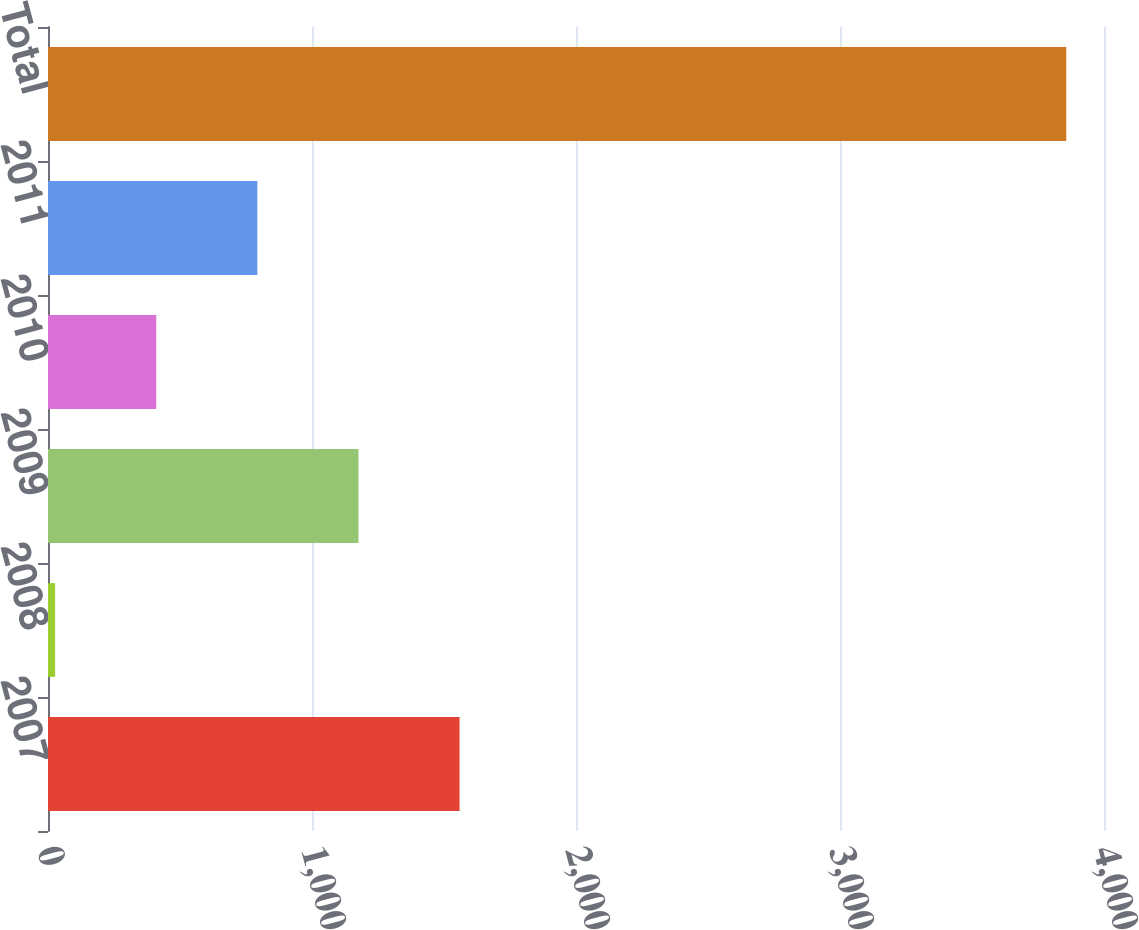<chart> <loc_0><loc_0><loc_500><loc_500><bar_chart><fcel>2007<fcel>2008<fcel>2009<fcel>2010<fcel>2011<fcel>Total<nl><fcel>1559<fcel>27<fcel>1176<fcel>410<fcel>793<fcel>3857<nl></chart> 